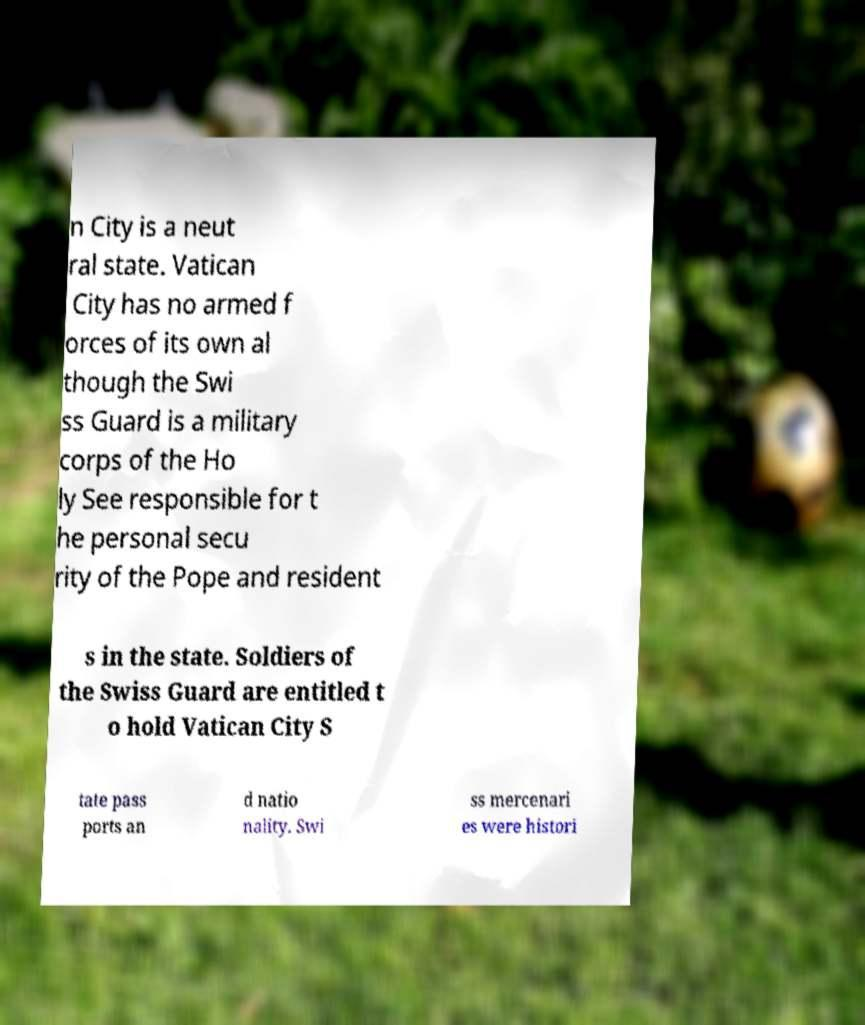Please read and relay the text visible in this image. What does it say? n City is a neut ral state. Vatican City has no armed f orces of its own al though the Swi ss Guard is a military corps of the Ho ly See responsible for t he personal secu rity of the Pope and resident s in the state. Soldiers of the Swiss Guard are entitled t o hold Vatican City S tate pass ports an d natio nality. Swi ss mercenari es were histori 